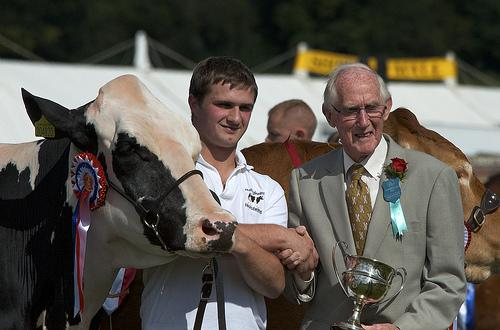What type of event is taking place in the image, based on the objects present? The image likely represents an award ceremony or a celebration, as there is a silver trophy and a ribbon. Provide a general sentiment of the image by observing the objects and their interactions. The sentiment of the image is celebratory, as there are people wearing suits, a trophy, and a ribbon. Identify the image's dominant color theme and objects present. The image primarily features black and white, with objects such as a man in a suit, a cow, a ribbon, a rose, and a trophy. Count the number of distinct red-colored objects in the image. There are three red-colored objects: two red roses and a red, white, and blue ribbon. Describe a unique detail about the cow in the image. The head of the cow is white and black, and there is a ribbon on the side of its head. Mention two people in the image and describe their appearances. A man wearing a gray suit with short brown hair, eyeglasses, and a brown tie; a boy wearing a white shirt with a yellow banner, standing near a cow. Which object in the image is being held by a man, and describe its appearance. A man is holding a silver trophy, which is small in size with a width of 85 and a height of 85 units. Examine the image and express an opinion on its quality and clarity of the objects present. The image quality is good, as the objects are well-defined, and their colors and positions are clear. What animal is present next to the boy, and what colors can you see on the animal? A cow is present next to the boy, and it has white and black colors on its head. Perform a simple reasoning task by identifying the relationship between the boy and the cow. Based on the image, it seems the boy could be participating in a competition or celebration involving the cow since they are standing near each other with a ribbon on the cow's head. Does the man's suit coat match the rest of his outfit? Yes, it is a gray suit coat. Explain the significance of the red rose in the scene. Unclear without additional context. Describe the man's appearance in the image. The man has short-cut brown hair, eyeglasses, and wears a gray suit with a brown tie. Describe the scene between the boy and the cow using a simile. The boy stood next to the cow as boldly as a matador. What part of the man's clothing corresponds to a red rose? None. Who is positioned closer to the cow: the boy or the man? The boy. Is it possible to determine the text or symbols depicted on the man's eyeglasses? No. Describe the cow's appearance, focusing on colors and parts. The head of the cow is white and black, while there's a red, white, and blue ribbon on the side of its head. Which of these does the man hold: a red rose, a silver trophy, or a white shirt? A silver trophy. List the prominent colors in the red rose's vicinity. Grey, white, and silver. What color is the ribbon on the side of the cow's head? Red, white, and blue. What are the colors of the cow's head? White and black. Determine if any event is taking place near the red rose. No specific event can be identified from the given information. Write a sentence about the boy's clothing using a metaphor. The boy's white shirt shone like a beacon next to the cow. Figure out the activity happening between the boy and the cow. The boy is standing next to the cow. Parse the detailed contents of the long yellow banner. Cannot determine from the given information. Create a thrilling sentence about the small trophy. The gleaming silver trophy awaited its triumphant owner with bated breath. What is happening near the boy with a white shirt? He is standing next to a cow that has a red, white and blue ribbon. Analyze the diagram for the relationship between the ribbon and the trophy. There is no clear relationship between the ribbon and the trophy in the given information. 